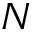<formula> <loc_0><loc_0><loc_500><loc_500>N</formula> 